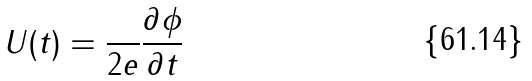<formula> <loc_0><loc_0><loc_500><loc_500>U ( t ) = \frac { } { 2 e } \frac { \partial \phi } { \partial t }</formula> 